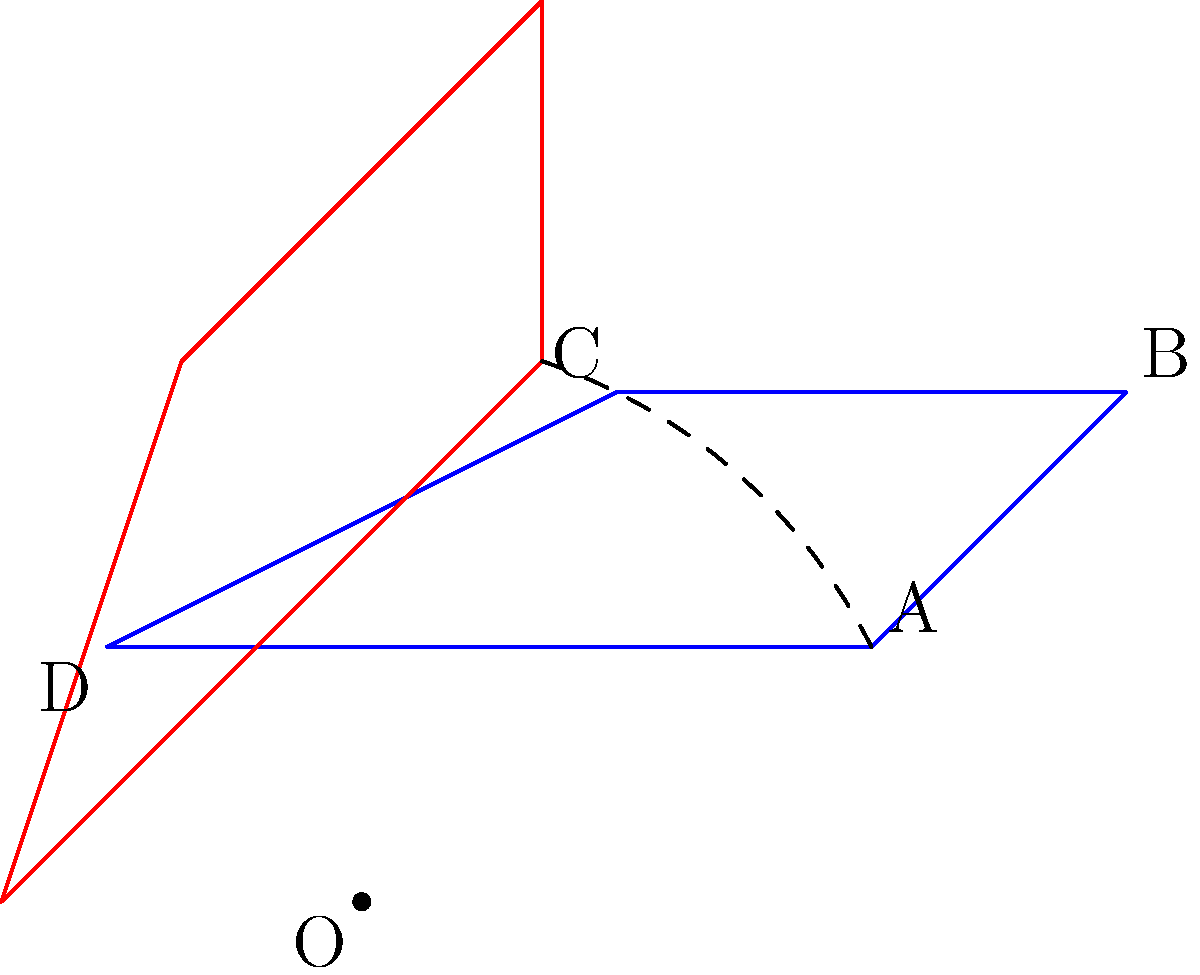A fish-shaped polygon ABCD is rotated 45° counterclockwise around point O. If the original coordinates of point A are (2,1), what are the coordinates of point A after rotation? To find the coordinates of point A after rotation, we can follow these steps:

1) The rotation matrix for a counterclockwise rotation by angle θ is:
   $$R = \begin{pmatrix} \cos θ & -\sin θ \\ \sin θ & \cos θ \end{pmatrix}$$

2) For a 45° rotation, θ = 45° = π/4 radians. We know that:
   $\cos(45°) = \sin(45°) = \frac{1}{\sqrt{2}} ≈ 0.707$

3) Substituting these values into the rotation matrix:
   $$R = \begin{pmatrix} 0.707 & -0.707 \\ 0.707 & 0.707 \end{pmatrix}$$

4) The original coordinates of A are (2,1). We can represent this as a column vector:
   $$A = \begin{pmatrix} 2 \\ 1 \end{pmatrix}$$

5) To find the new coordinates, we multiply the rotation matrix by the original coordinates:
   $$A' = R \cdot A = \begin{pmatrix} 0.707 & -0.707 \\ 0.707 & 0.707 \end{pmatrix} \cdot \begin{pmatrix} 2 \\ 1 \end{pmatrix}$$

6) Performing the matrix multiplication:
   $$A' = \begin{pmatrix} (0.707 \cdot 2) + (-0.707 \cdot 1) \\ (0.707 \cdot 2) + (0.707 \cdot 1) \end{pmatrix} = \begin{pmatrix} 0.707 \\ 2.121 \end{pmatrix}$$

7) Therefore, the new coordinates of point A after rotation are approximately (0.707, 2.121).
Answer: (0.707, 2.121) 